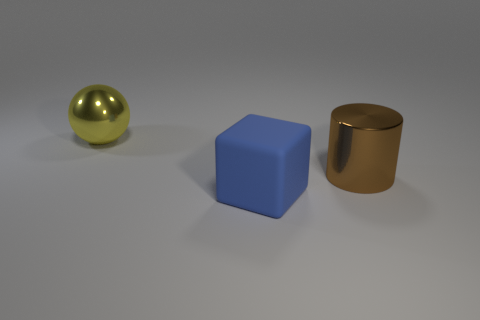The sphere that is made of the same material as the big cylinder is what color?
Offer a terse response. Yellow. Is the blue matte thing the same size as the brown cylinder?
Give a very brief answer. Yes. What number of shiny cylinders are the same color as the matte cube?
Provide a short and direct response. 0. There is a large object in front of the big metal object on the right side of the large metal thing behind the large brown metal thing; what is it made of?
Give a very brief answer. Rubber. The object that is in front of the large metal object on the right side of the yellow sphere is what color?
Give a very brief answer. Blue. How many big things are either rubber things or brown metal cylinders?
Offer a terse response. 2. What number of tiny gray cylinders have the same material as the sphere?
Give a very brief answer. 0. There is a metal object left of the cylinder; what is its size?
Your answer should be compact. Large. What is the shape of the shiny object that is to the right of the metal object on the left side of the large brown metal cylinder?
Your answer should be very brief. Cylinder. There is a big metal thing to the right of the block to the left of the large brown shiny cylinder; what number of large yellow metallic spheres are on the left side of it?
Keep it short and to the point. 1. 